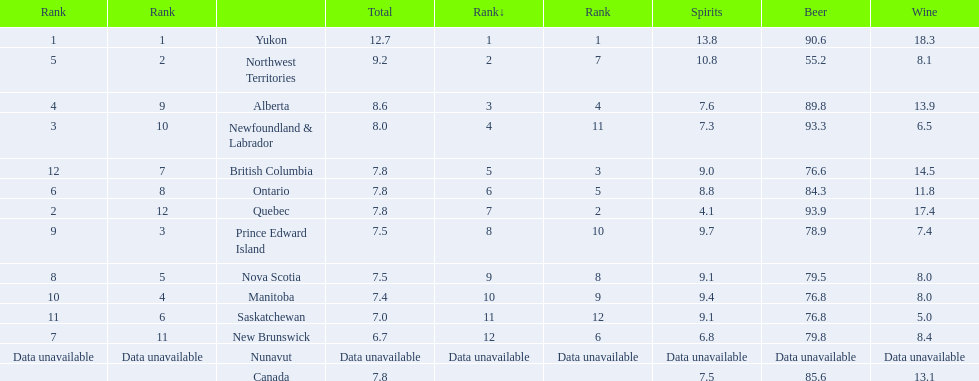What is the first ranked alcoholic beverage in canada Yukon. How many litters is consumed a year? 12.7. 